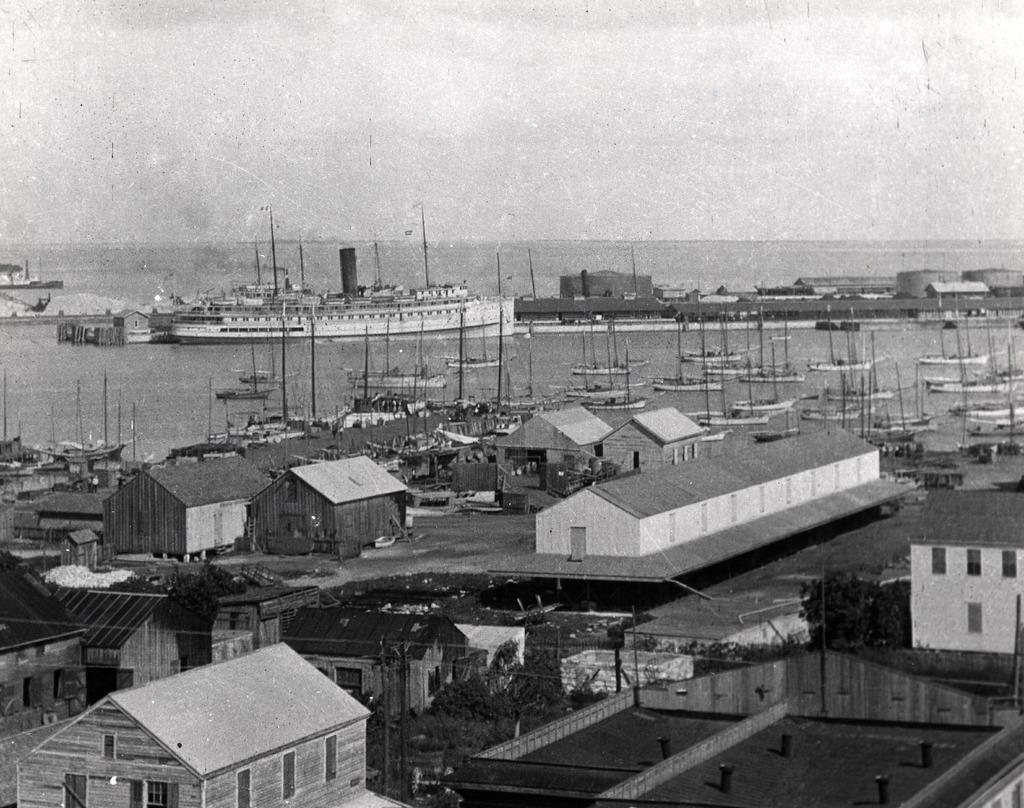What is the color scheme of the image? The image is black and white. What type of structures can be seen in the image? There are sheds in the image. What type of vegetation is present in the image? There are trees in the image. What are the tall, thin objects in the image? There are poles in the image. What type of vehicles are in the water in the image? There are ships and boats in the water in the image. What type of substance is being used to clean the trousers in the image? There are no trousers or cleaning substances present in the image. What color are the wristbands worn by the people in the image? There are no people or wristbands present in the image. 